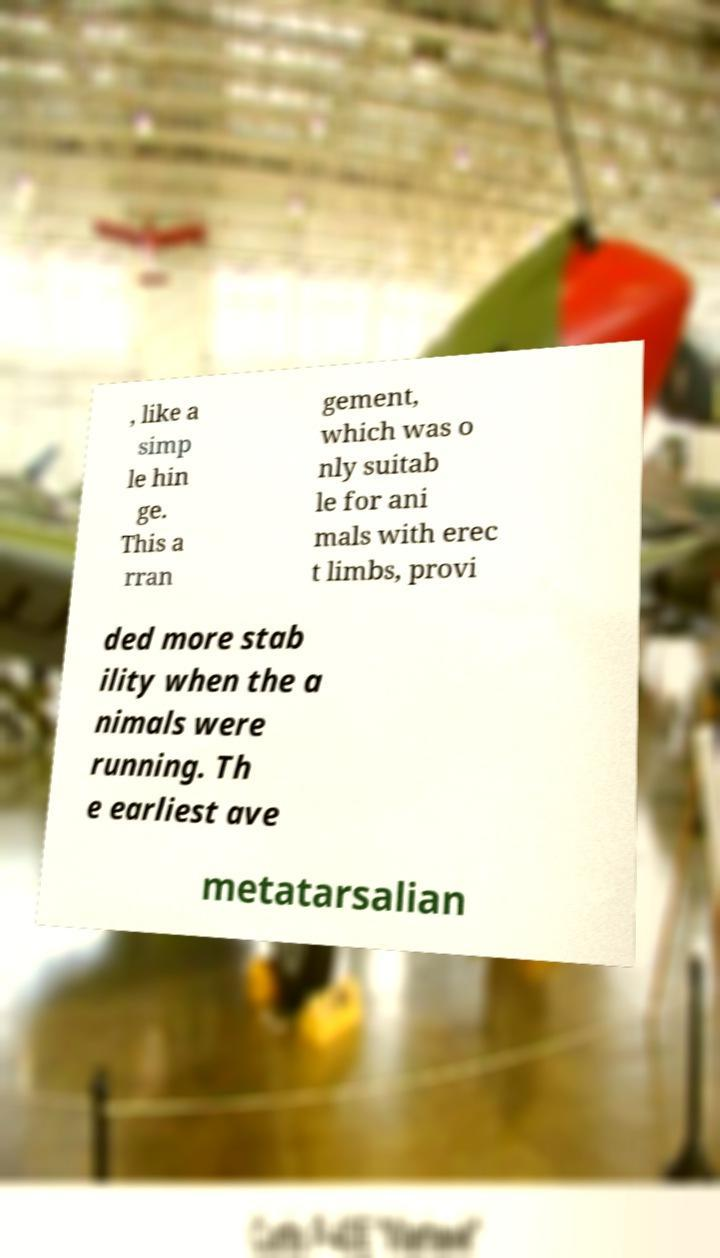Could you extract and type out the text from this image? , like a simp le hin ge. This a rran gement, which was o nly suitab le for ani mals with erec t limbs, provi ded more stab ility when the a nimals were running. Th e earliest ave metatarsalian 